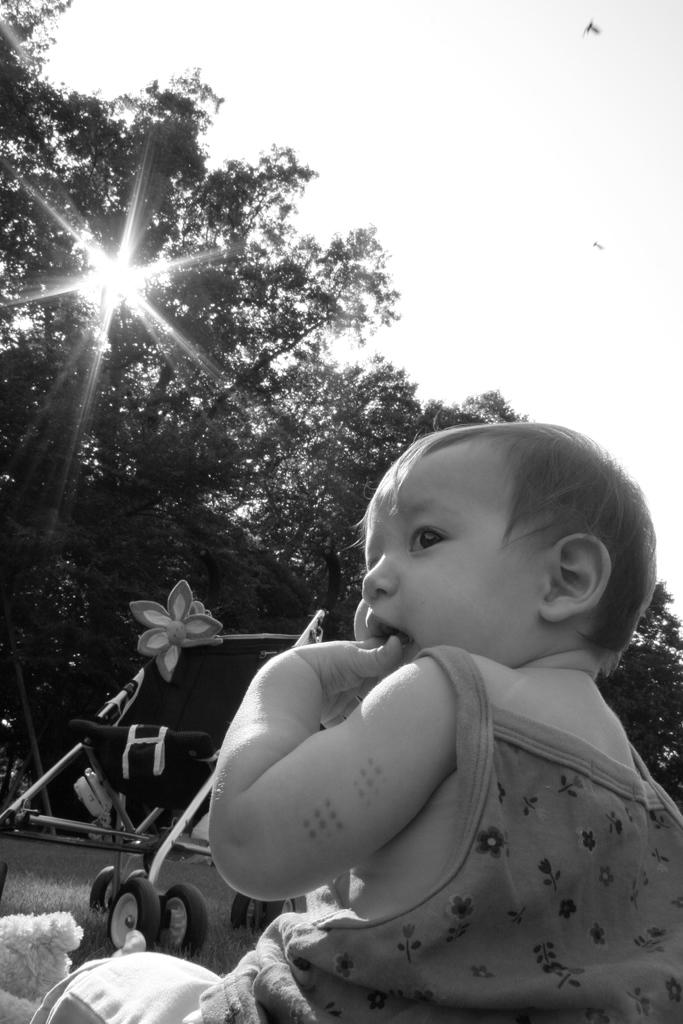What is the main subject of the image? There is a child in the image. What else can be seen on the ground in the image? There is a vehicle on the ground in the image. What type of natural elements are present in the image? There are trees in the image. What can be seen in the distance in the image? The sky is visible in the background of the image. How many chickens are present in the image? There are no chickens present in the image. What type of food is the child eating in the image? The provided facts do not mention any food in the image, so it cannot be determined from the image. 